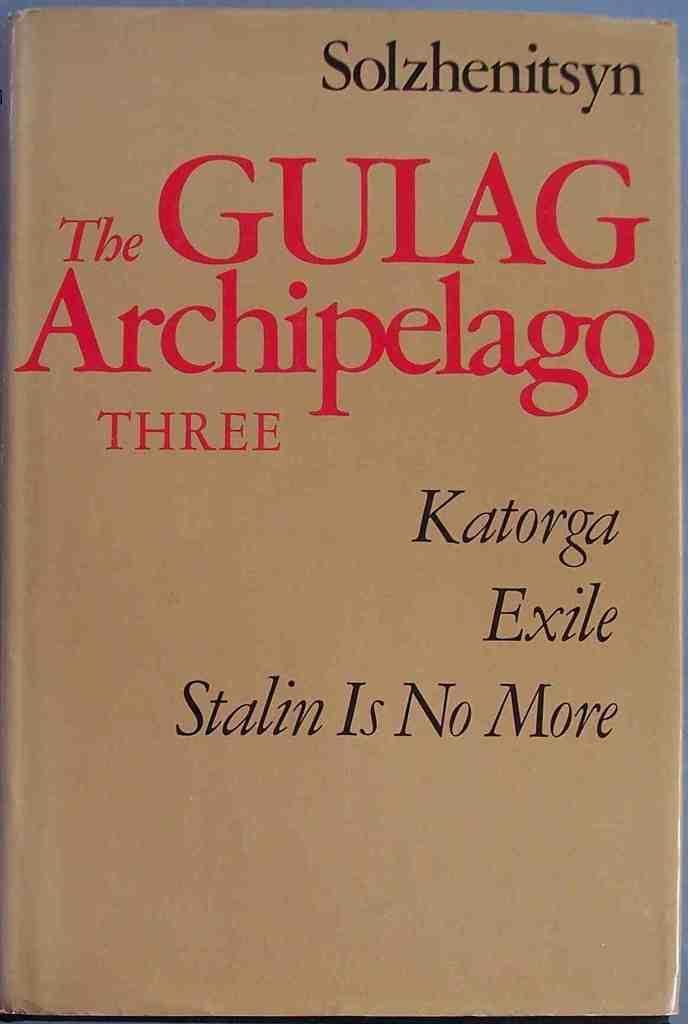In one or two sentences, can you explain what this image depicts? This is the picture of a cover of a book on which there are some things written with red and black color. 